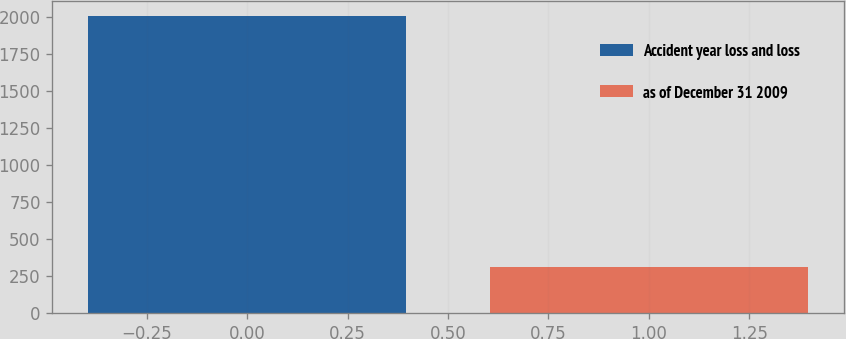Convert chart. <chart><loc_0><loc_0><loc_500><loc_500><bar_chart><fcel>Accident year loss and loss<fcel>as of December 31 2009<nl><fcel>2007<fcel>310<nl></chart> 